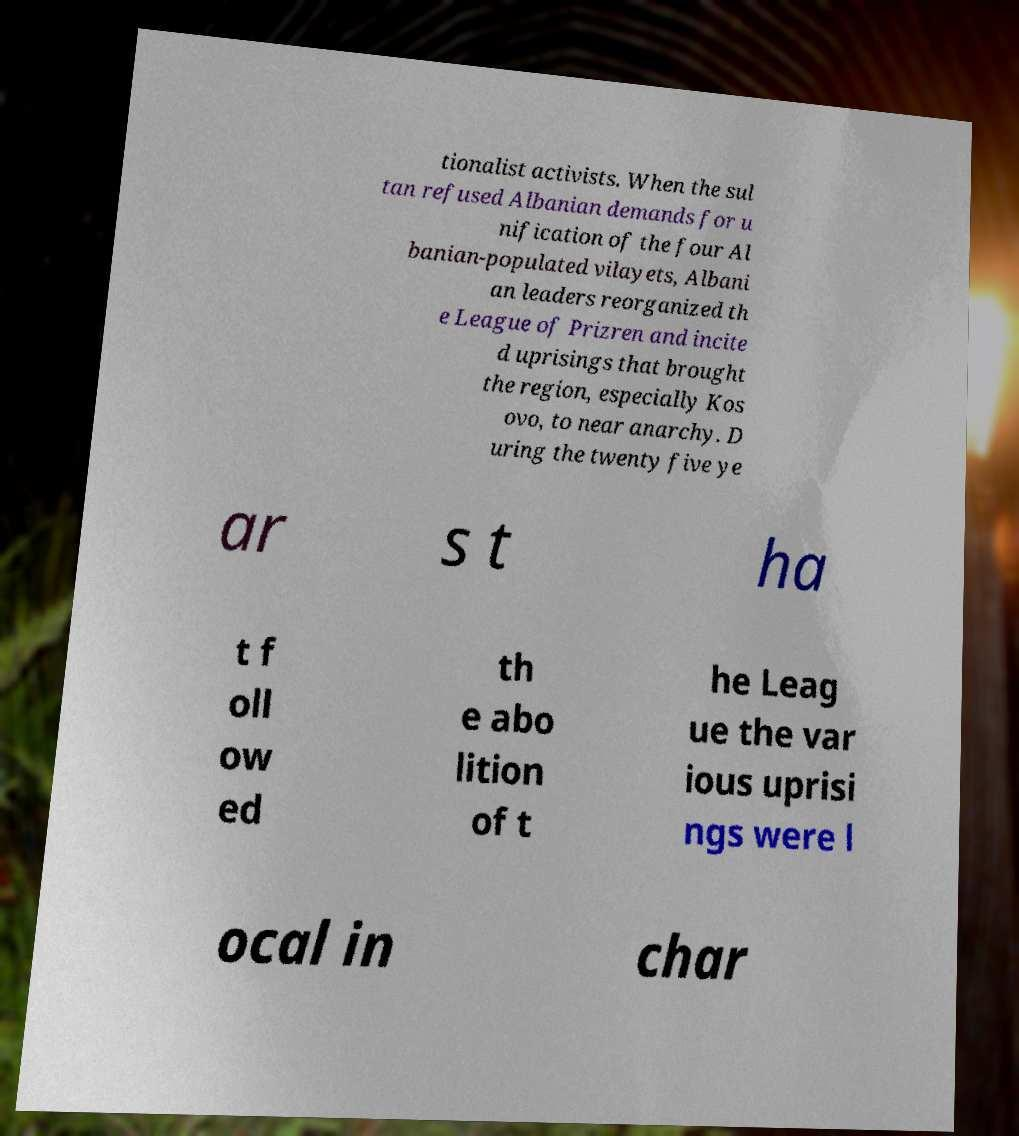Could you extract and type out the text from this image? tionalist activists. When the sul tan refused Albanian demands for u nification of the four Al banian-populated vilayets, Albani an leaders reorganized th e League of Prizren and incite d uprisings that brought the region, especially Kos ovo, to near anarchy. D uring the twenty five ye ar s t ha t f oll ow ed th e abo lition of t he Leag ue the var ious uprisi ngs were l ocal in char 